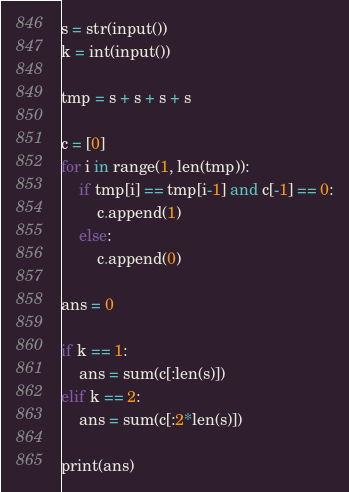<code> <loc_0><loc_0><loc_500><loc_500><_Python_>s = str(input())
k = int(input())
 
tmp = s + s + s + s
 
c = [0]
for i in range(1, len(tmp)):
    if tmp[i] == tmp[i-1] and c[-1] == 0:
        c.append(1)
    else:
        c.append(0)
 
ans = 0
 
if k == 1:
    ans = sum(c[:len(s)])
elif k == 2:
    ans = sum(c[:2*len(s)])
    
print(ans)</code> 